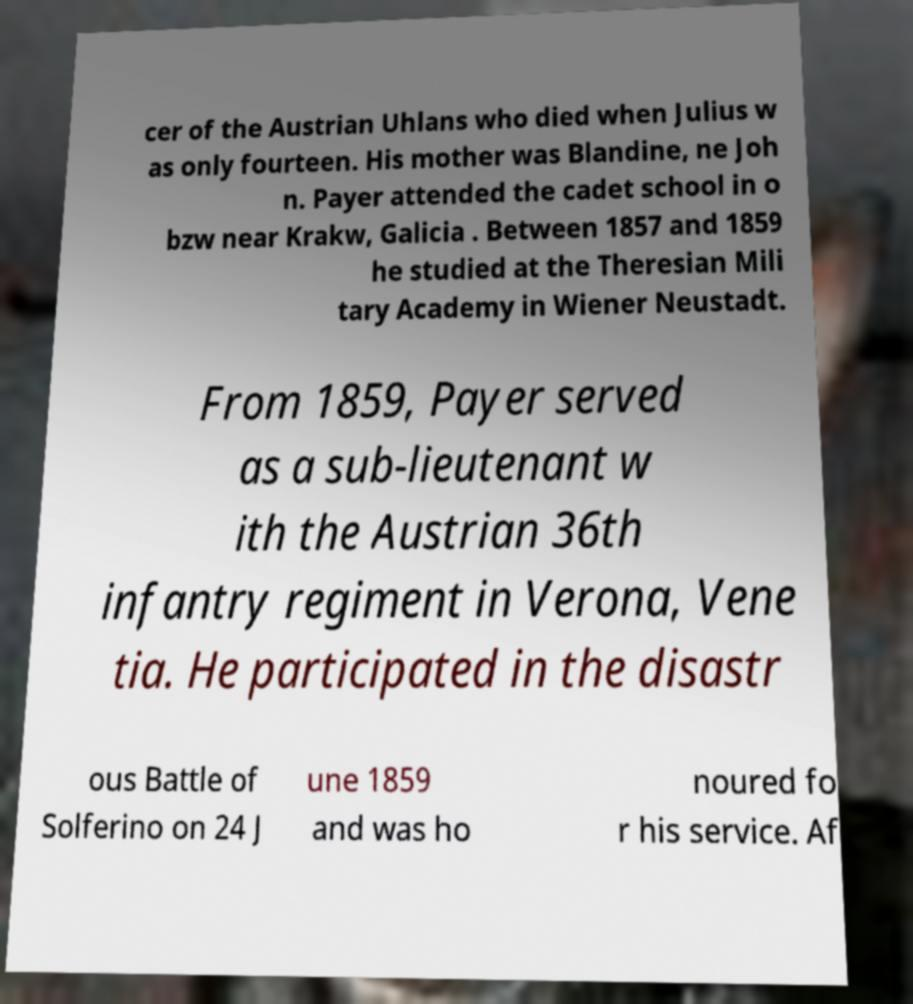For documentation purposes, I need the text within this image transcribed. Could you provide that? cer of the Austrian Uhlans who died when Julius w as only fourteen. His mother was Blandine, ne Joh n. Payer attended the cadet school in o bzw near Krakw, Galicia . Between 1857 and 1859 he studied at the Theresian Mili tary Academy in Wiener Neustadt. From 1859, Payer served as a sub-lieutenant w ith the Austrian 36th infantry regiment in Verona, Vene tia. He participated in the disastr ous Battle of Solferino on 24 J une 1859 and was ho noured fo r his service. Af 